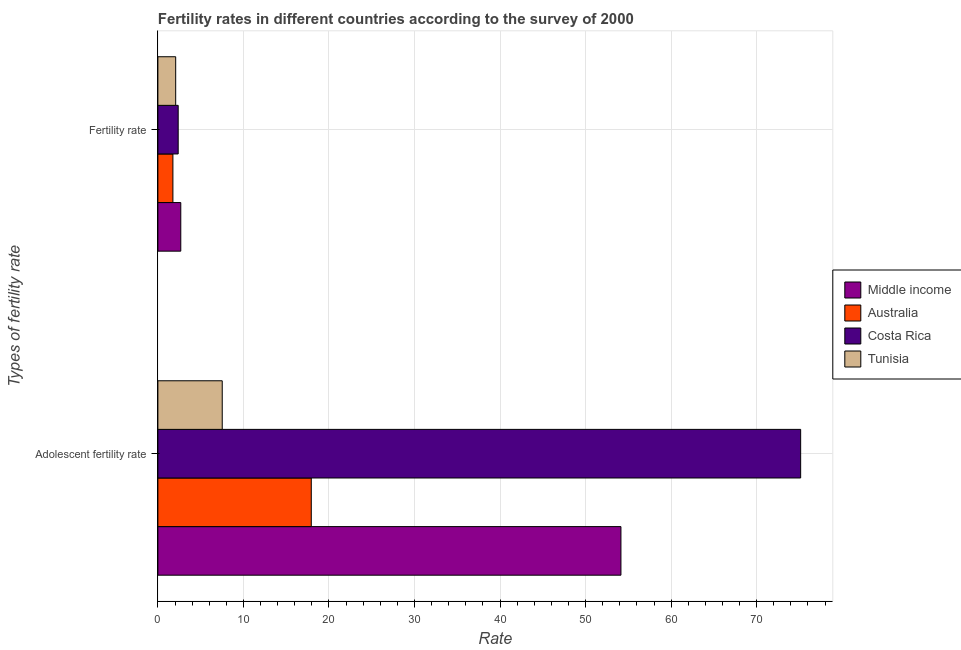How many different coloured bars are there?
Your answer should be compact. 4. How many groups of bars are there?
Provide a succinct answer. 2. Are the number of bars per tick equal to the number of legend labels?
Provide a short and direct response. Yes. How many bars are there on the 2nd tick from the top?
Provide a short and direct response. 4. How many bars are there on the 2nd tick from the bottom?
Your answer should be very brief. 4. What is the label of the 1st group of bars from the top?
Offer a terse response. Fertility rate. What is the fertility rate in Costa Rica?
Give a very brief answer. 2.37. Across all countries, what is the maximum fertility rate?
Make the answer very short. 2.68. Across all countries, what is the minimum adolescent fertility rate?
Ensure brevity in your answer.  7.52. In which country was the adolescent fertility rate maximum?
Your answer should be very brief. Costa Rica. In which country was the adolescent fertility rate minimum?
Offer a terse response. Tunisia. What is the total fertility rate in the graph?
Make the answer very short. 8.89. What is the difference between the fertility rate in Costa Rica and that in Australia?
Ensure brevity in your answer.  0.62. What is the difference between the fertility rate in Australia and the adolescent fertility rate in Costa Rica?
Ensure brevity in your answer.  -73.39. What is the average fertility rate per country?
Make the answer very short. 2.22. What is the difference between the adolescent fertility rate and fertility rate in Tunisia?
Offer a very short reply. 5.44. In how many countries, is the fertility rate greater than 20 ?
Ensure brevity in your answer.  0. What is the ratio of the fertility rate in Tunisia to that in Costa Rica?
Provide a short and direct response. 0.88. In how many countries, is the adolescent fertility rate greater than the average adolescent fertility rate taken over all countries?
Ensure brevity in your answer.  2. What does the 1st bar from the top in Fertility rate represents?
Offer a terse response. Tunisia. What does the 2nd bar from the bottom in Fertility rate represents?
Keep it short and to the point. Australia. How many bars are there?
Make the answer very short. 8. How many countries are there in the graph?
Make the answer very short. 4. What is the difference between two consecutive major ticks on the X-axis?
Give a very brief answer. 10. Are the values on the major ticks of X-axis written in scientific E-notation?
Give a very brief answer. No. Does the graph contain any zero values?
Give a very brief answer. No. Does the graph contain grids?
Give a very brief answer. Yes. Where does the legend appear in the graph?
Make the answer very short. Center right. How many legend labels are there?
Provide a short and direct response. 4. How are the legend labels stacked?
Offer a very short reply. Vertical. What is the title of the graph?
Offer a very short reply. Fertility rates in different countries according to the survey of 2000. Does "Togo" appear as one of the legend labels in the graph?
Provide a short and direct response. No. What is the label or title of the X-axis?
Provide a succinct answer. Rate. What is the label or title of the Y-axis?
Offer a very short reply. Types of fertility rate. What is the Rate in Middle income in Adolescent fertility rate?
Your answer should be very brief. 54.13. What is the Rate in Australia in Adolescent fertility rate?
Provide a succinct answer. 17.93. What is the Rate of Costa Rica in Adolescent fertility rate?
Offer a terse response. 75.14. What is the Rate in Tunisia in Adolescent fertility rate?
Offer a terse response. 7.52. What is the Rate of Middle income in Fertility rate?
Offer a very short reply. 2.68. What is the Rate in Australia in Fertility rate?
Ensure brevity in your answer.  1.76. What is the Rate in Costa Rica in Fertility rate?
Your answer should be very brief. 2.37. What is the Rate of Tunisia in Fertility rate?
Provide a short and direct response. 2.08. Across all Types of fertility rate, what is the maximum Rate in Middle income?
Make the answer very short. 54.13. Across all Types of fertility rate, what is the maximum Rate in Australia?
Keep it short and to the point. 17.93. Across all Types of fertility rate, what is the maximum Rate in Costa Rica?
Your response must be concise. 75.14. Across all Types of fertility rate, what is the maximum Rate in Tunisia?
Keep it short and to the point. 7.52. Across all Types of fertility rate, what is the minimum Rate of Middle income?
Give a very brief answer. 2.68. Across all Types of fertility rate, what is the minimum Rate in Australia?
Give a very brief answer. 1.76. Across all Types of fertility rate, what is the minimum Rate of Costa Rica?
Your response must be concise. 2.37. Across all Types of fertility rate, what is the minimum Rate in Tunisia?
Ensure brevity in your answer.  2.08. What is the total Rate of Middle income in the graph?
Your response must be concise. 56.81. What is the total Rate in Australia in the graph?
Your answer should be very brief. 19.69. What is the total Rate of Costa Rica in the graph?
Make the answer very short. 77.52. What is the total Rate of Tunisia in the graph?
Provide a short and direct response. 9.6. What is the difference between the Rate in Middle income in Adolescent fertility rate and that in Fertility rate?
Keep it short and to the point. 51.46. What is the difference between the Rate in Australia in Adolescent fertility rate and that in Fertility rate?
Your answer should be compact. 16.18. What is the difference between the Rate in Costa Rica in Adolescent fertility rate and that in Fertility rate?
Your answer should be compact. 72.77. What is the difference between the Rate in Tunisia in Adolescent fertility rate and that in Fertility rate?
Ensure brevity in your answer.  5.44. What is the difference between the Rate in Middle income in Adolescent fertility rate and the Rate in Australia in Fertility rate?
Your answer should be very brief. 52.38. What is the difference between the Rate of Middle income in Adolescent fertility rate and the Rate of Costa Rica in Fertility rate?
Your answer should be very brief. 51.76. What is the difference between the Rate of Middle income in Adolescent fertility rate and the Rate of Tunisia in Fertility rate?
Your answer should be very brief. 52.05. What is the difference between the Rate in Australia in Adolescent fertility rate and the Rate in Costa Rica in Fertility rate?
Provide a short and direct response. 15.56. What is the difference between the Rate of Australia in Adolescent fertility rate and the Rate of Tunisia in Fertility rate?
Provide a succinct answer. 15.85. What is the difference between the Rate in Costa Rica in Adolescent fertility rate and the Rate in Tunisia in Fertility rate?
Ensure brevity in your answer.  73.06. What is the average Rate in Middle income per Types of fertility rate?
Make the answer very short. 28.4. What is the average Rate in Australia per Types of fertility rate?
Provide a short and direct response. 9.84. What is the average Rate of Costa Rica per Types of fertility rate?
Keep it short and to the point. 38.76. What is the average Rate in Tunisia per Types of fertility rate?
Your answer should be compact. 4.8. What is the difference between the Rate in Middle income and Rate in Australia in Adolescent fertility rate?
Your answer should be compact. 36.2. What is the difference between the Rate of Middle income and Rate of Costa Rica in Adolescent fertility rate?
Your answer should be compact. -21.01. What is the difference between the Rate of Middle income and Rate of Tunisia in Adolescent fertility rate?
Your answer should be very brief. 46.61. What is the difference between the Rate in Australia and Rate in Costa Rica in Adolescent fertility rate?
Offer a very short reply. -57.21. What is the difference between the Rate in Australia and Rate in Tunisia in Adolescent fertility rate?
Offer a very short reply. 10.41. What is the difference between the Rate of Costa Rica and Rate of Tunisia in Adolescent fertility rate?
Ensure brevity in your answer.  67.62. What is the difference between the Rate in Middle income and Rate in Costa Rica in Fertility rate?
Keep it short and to the point. 0.3. What is the difference between the Rate in Middle income and Rate in Tunisia in Fertility rate?
Give a very brief answer. 0.6. What is the difference between the Rate of Australia and Rate of Costa Rica in Fertility rate?
Give a very brief answer. -0.62. What is the difference between the Rate of Australia and Rate of Tunisia in Fertility rate?
Offer a terse response. -0.32. What is the difference between the Rate in Costa Rica and Rate in Tunisia in Fertility rate?
Make the answer very short. 0.29. What is the ratio of the Rate in Middle income in Adolescent fertility rate to that in Fertility rate?
Offer a terse response. 20.23. What is the ratio of the Rate in Australia in Adolescent fertility rate to that in Fertility rate?
Give a very brief answer. 10.21. What is the ratio of the Rate of Costa Rica in Adolescent fertility rate to that in Fertility rate?
Ensure brevity in your answer.  31.67. What is the ratio of the Rate of Tunisia in Adolescent fertility rate to that in Fertility rate?
Provide a succinct answer. 3.62. What is the difference between the highest and the second highest Rate of Middle income?
Ensure brevity in your answer.  51.46. What is the difference between the highest and the second highest Rate in Australia?
Your answer should be compact. 16.18. What is the difference between the highest and the second highest Rate of Costa Rica?
Provide a short and direct response. 72.77. What is the difference between the highest and the second highest Rate of Tunisia?
Ensure brevity in your answer.  5.44. What is the difference between the highest and the lowest Rate in Middle income?
Offer a very short reply. 51.46. What is the difference between the highest and the lowest Rate in Australia?
Provide a short and direct response. 16.18. What is the difference between the highest and the lowest Rate of Costa Rica?
Provide a short and direct response. 72.77. What is the difference between the highest and the lowest Rate of Tunisia?
Offer a very short reply. 5.44. 